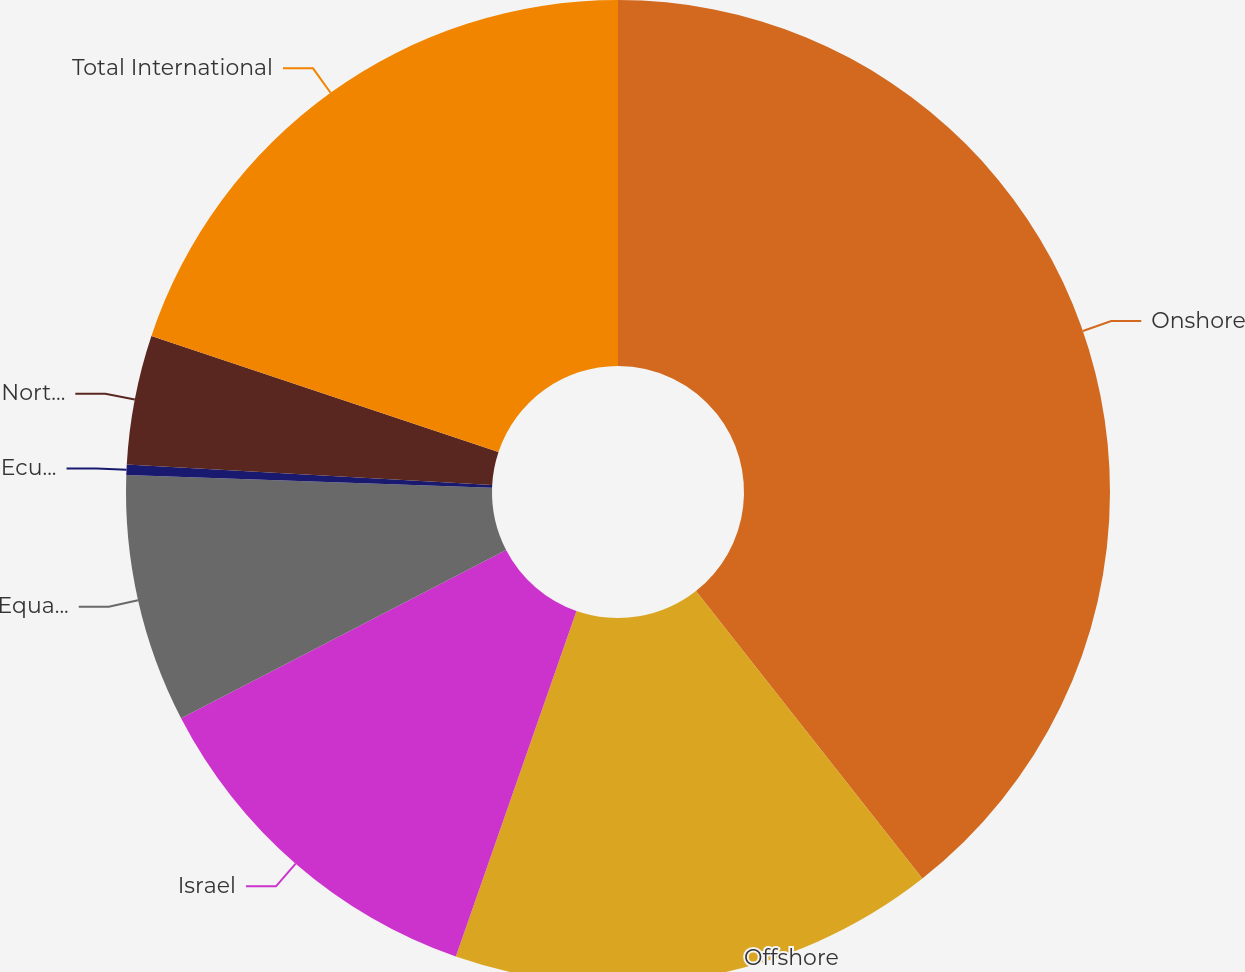Convert chart to OTSL. <chart><loc_0><loc_0><loc_500><loc_500><pie_chart><fcel>Onshore<fcel>Offshore<fcel>Israel<fcel>Equatorial Guinea<fcel>Ecuador<fcel>North Sea (1)<fcel>Total International<nl><fcel>39.38%<fcel>15.96%<fcel>12.05%<fcel>8.15%<fcel>0.34%<fcel>4.25%<fcel>19.86%<nl></chart> 